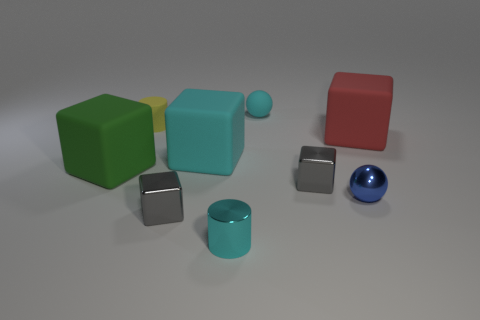Subtract all small shiny cubes. How many cubes are left? 3 Add 1 large matte blocks. How many objects exist? 10 Subtract all cyan blocks. How many blocks are left? 4 Subtract all blocks. How many objects are left? 4 Subtract 1 cylinders. How many cylinders are left? 1 Subtract all cyan cylinders. Subtract all gray spheres. How many cylinders are left? 1 Subtract all cyan cylinders. How many cyan spheres are left? 1 Subtract all metallic balls. Subtract all small shiny balls. How many objects are left? 7 Add 6 small cylinders. How many small cylinders are left? 8 Add 4 tiny cyan rubber blocks. How many tiny cyan rubber blocks exist? 4 